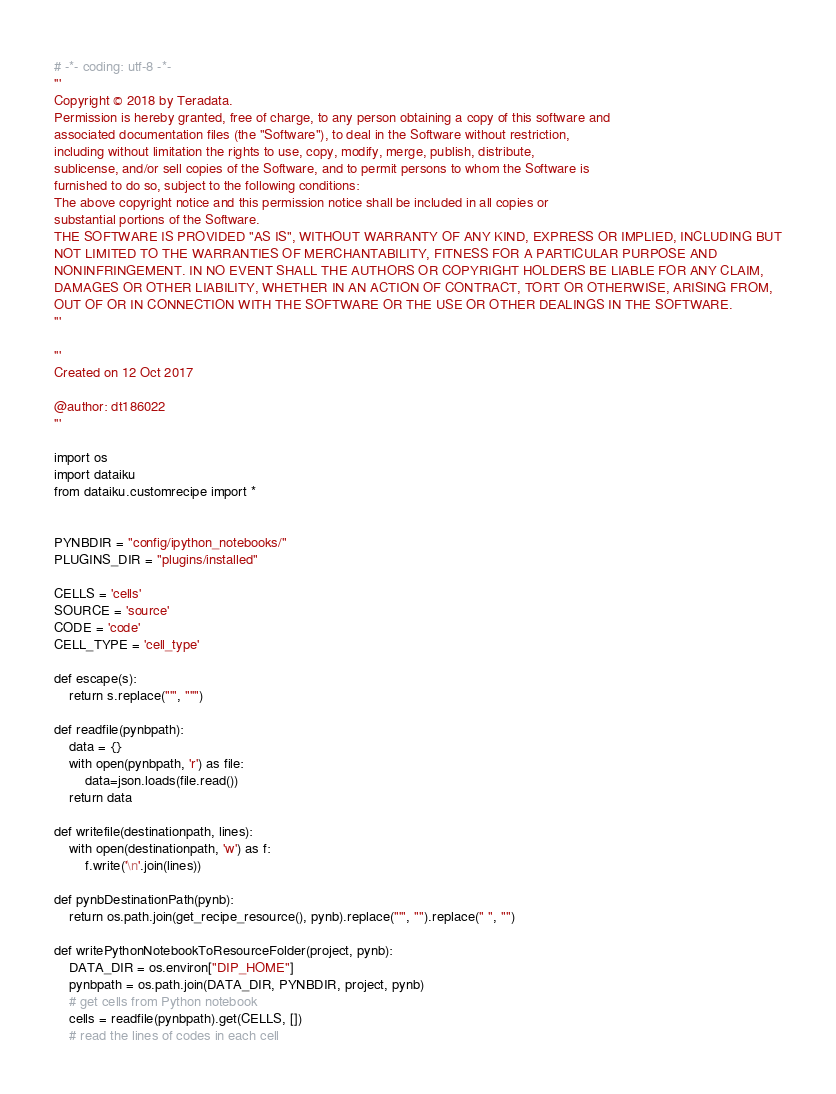Convert code to text. <code><loc_0><loc_0><loc_500><loc_500><_Python_># -*- coding: utf-8 -*-
'''
Copyright © 2018 by Teradata.
Permission is hereby granted, free of charge, to any person obtaining a copy of this software and
associated documentation files (the "Software"), to deal in the Software without restriction,
including without limitation the rights to use, copy, modify, merge, publish, distribute,
sublicense, and/or sell copies of the Software, and to permit persons to whom the Software is
furnished to do so, subject to the following conditions:
The above copyright notice and this permission notice shall be included in all copies or
substantial portions of the Software.
THE SOFTWARE IS PROVIDED "AS IS", WITHOUT WARRANTY OF ANY KIND, EXPRESS OR IMPLIED, INCLUDING BUT
NOT LIMITED TO THE WARRANTIES OF MERCHANTABILITY, FITNESS FOR A PARTICULAR PURPOSE AND
NONINFRINGEMENT. IN NO EVENT SHALL THE AUTHORS OR COPYRIGHT HOLDERS BE LIABLE FOR ANY CLAIM,
DAMAGES OR OTHER LIABILITY, WHETHER IN AN ACTION OF CONTRACT, TORT OR OTHERWISE, ARISING FROM,
OUT OF OR IN CONNECTION WITH THE SOFTWARE OR THE USE OR OTHER DEALINGS IN THE SOFTWARE.
'''

'''
Created on 12 Oct 2017

@author: dt186022
'''

import os
import dataiku
from dataiku.customrecipe import *


PYNBDIR = "config/ipython_notebooks/"
PLUGINS_DIR = "plugins/installed"

CELLS = 'cells'
SOURCE = 'source'
CODE = 'code'
CELL_TYPE = 'cell_type'

def escape(s):
    return s.replace("'", "''")

def readfile(pynbpath):
    data = {}
    with open(pynbpath, 'r') as file:
        data=json.loads(file.read())
    return data

def writefile(destinationpath, lines):
    with open(destinationpath, 'w') as f:
        f.write('\n'.join(lines))

def pynbDestinationPath(pynb):
    return os.path.join(get_recipe_resource(), pynb).replace("'", "").replace(" ", "")

def writePythonNotebookToResourceFolder(project, pynb):
    DATA_DIR = os.environ["DIP_HOME"]
    pynbpath = os.path.join(DATA_DIR, PYNBDIR, project, pynb)
    # get cells from Python notebook
    cells = readfile(pynbpath).get(CELLS, [])
    # read the lines of codes in each cell</code> 